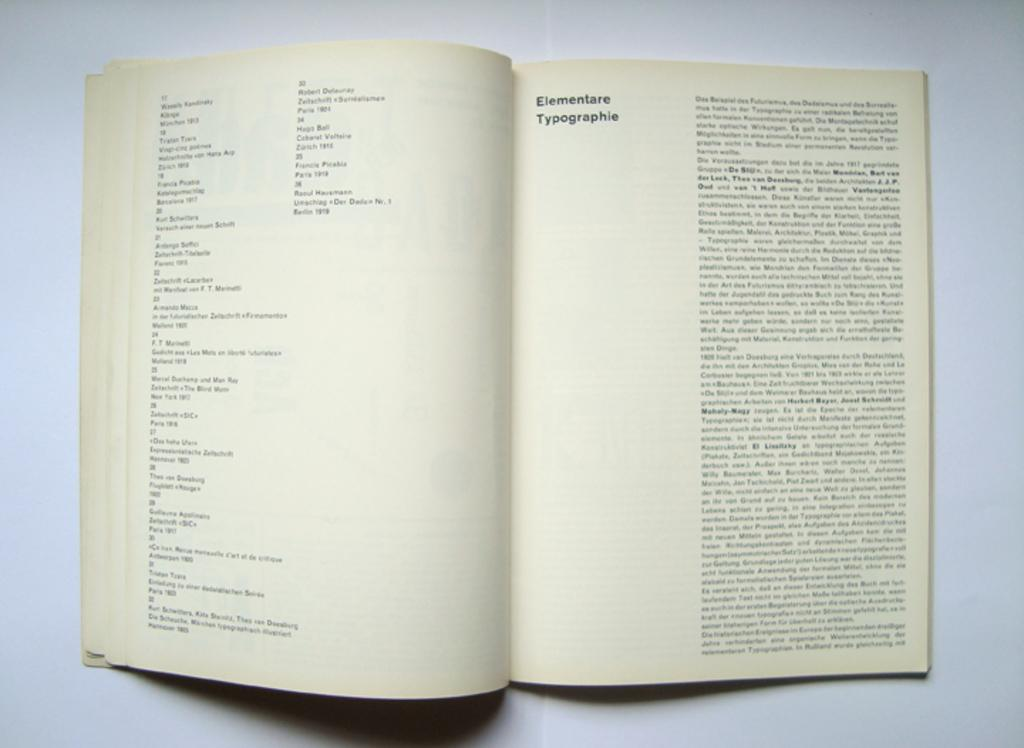<image>
Provide a brief description of the given image. Open book on a page titled Elementare Typographie. 